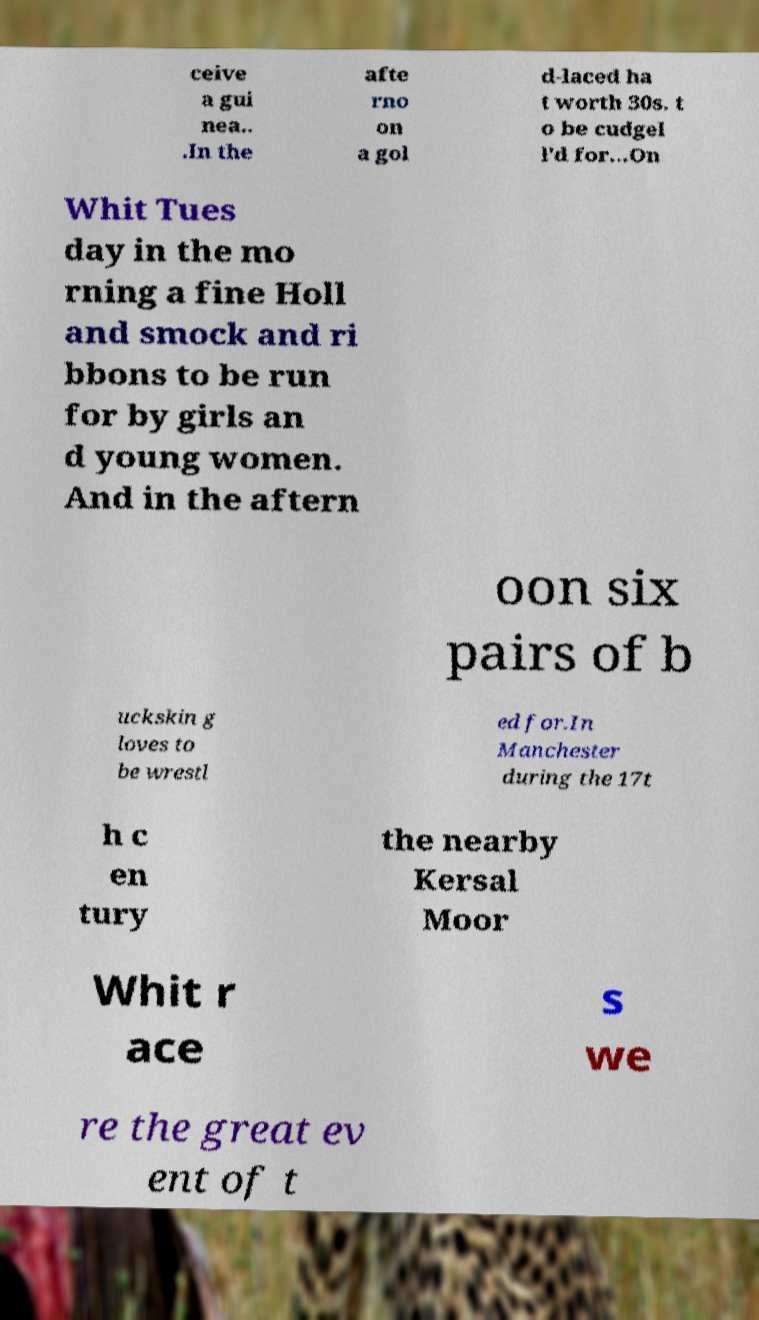I need the written content from this picture converted into text. Can you do that? ceive a gui nea.. .In the afte rno on a gol d-laced ha t worth 30s. t o be cudgel l'd for...On Whit Tues day in the mo rning a fine Holl and smock and ri bbons to be run for by girls an d young women. And in the aftern oon six pairs of b uckskin g loves to be wrestl ed for.In Manchester during the 17t h c en tury the nearby Kersal Moor Whit r ace s we re the great ev ent of t 